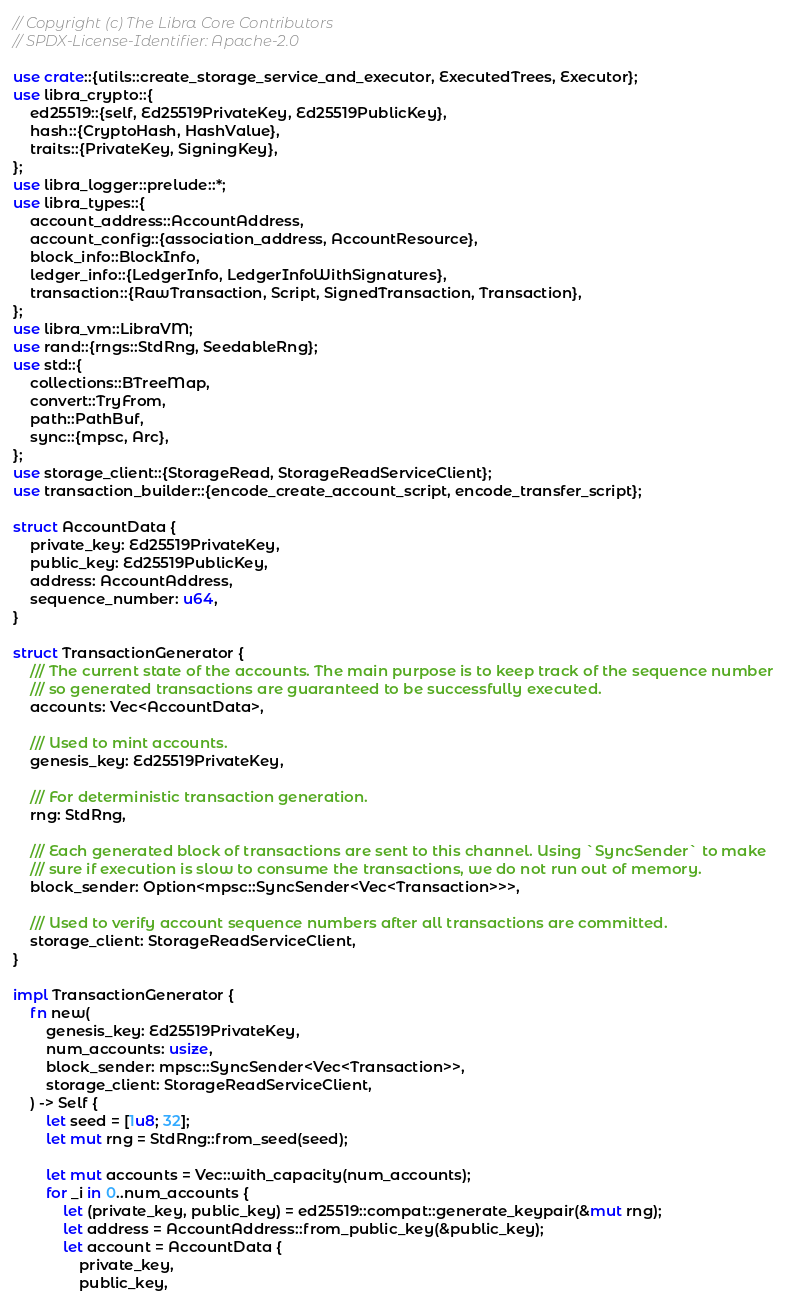<code> <loc_0><loc_0><loc_500><loc_500><_Rust_>// Copyright (c) The Libra Core Contributors
// SPDX-License-Identifier: Apache-2.0

use crate::{utils::create_storage_service_and_executor, ExecutedTrees, Executor};
use libra_crypto::{
    ed25519::{self, Ed25519PrivateKey, Ed25519PublicKey},
    hash::{CryptoHash, HashValue},
    traits::{PrivateKey, SigningKey},
};
use libra_logger::prelude::*;
use libra_types::{
    account_address::AccountAddress,
    account_config::{association_address, AccountResource},
    block_info::BlockInfo,
    ledger_info::{LedgerInfo, LedgerInfoWithSignatures},
    transaction::{RawTransaction, Script, SignedTransaction, Transaction},
};
use libra_vm::LibraVM;
use rand::{rngs::StdRng, SeedableRng};
use std::{
    collections::BTreeMap,
    convert::TryFrom,
    path::PathBuf,
    sync::{mpsc, Arc},
};
use storage_client::{StorageRead, StorageReadServiceClient};
use transaction_builder::{encode_create_account_script, encode_transfer_script};

struct AccountData {
    private_key: Ed25519PrivateKey,
    public_key: Ed25519PublicKey,
    address: AccountAddress,
    sequence_number: u64,
}

struct TransactionGenerator {
    /// The current state of the accounts. The main purpose is to keep track of the sequence number
    /// so generated transactions are guaranteed to be successfully executed.
    accounts: Vec<AccountData>,

    /// Used to mint accounts.
    genesis_key: Ed25519PrivateKey,

    /// For deterministic transaction generation.
    rng: StdRng,

    /// Each generated block of transactions are sent to this channel. Using `SyncSender` to make
    /// sure if execution is slow to consume the transactions, we do not run out of memory.
    block_sender: Option<mpsc::SyncSender<Vec<Transaction>>>,

    /// Used to verify account sequence numbers after all transactions are committed.
    storage_client: StorageReadServiceClient,
}

impl TransactionGenerator {
    fn new(
        genesis_key: Ed25519PrivateKey,
        num_accounts: usize,
        block_sender: mpsc::SyncSender<Vec<Transaction>>,
        storage_client: StorageReadServiceClient,
    ) -> Self {
        let seed = [1u8; 32];
        let mut rng = StdRng::from_seed(seed);

        let mut accounts = Vec::with_capacity(num_accounts);
        for _i in 0..num_accounts {
            let (private_key, public_key) = ed25519::compat::generate_keypair(&mut rng);
            let address = AccountAddress::from_public_key(&public_key);
            let account = AccountData {
                private_key,
                public_key,</code> 